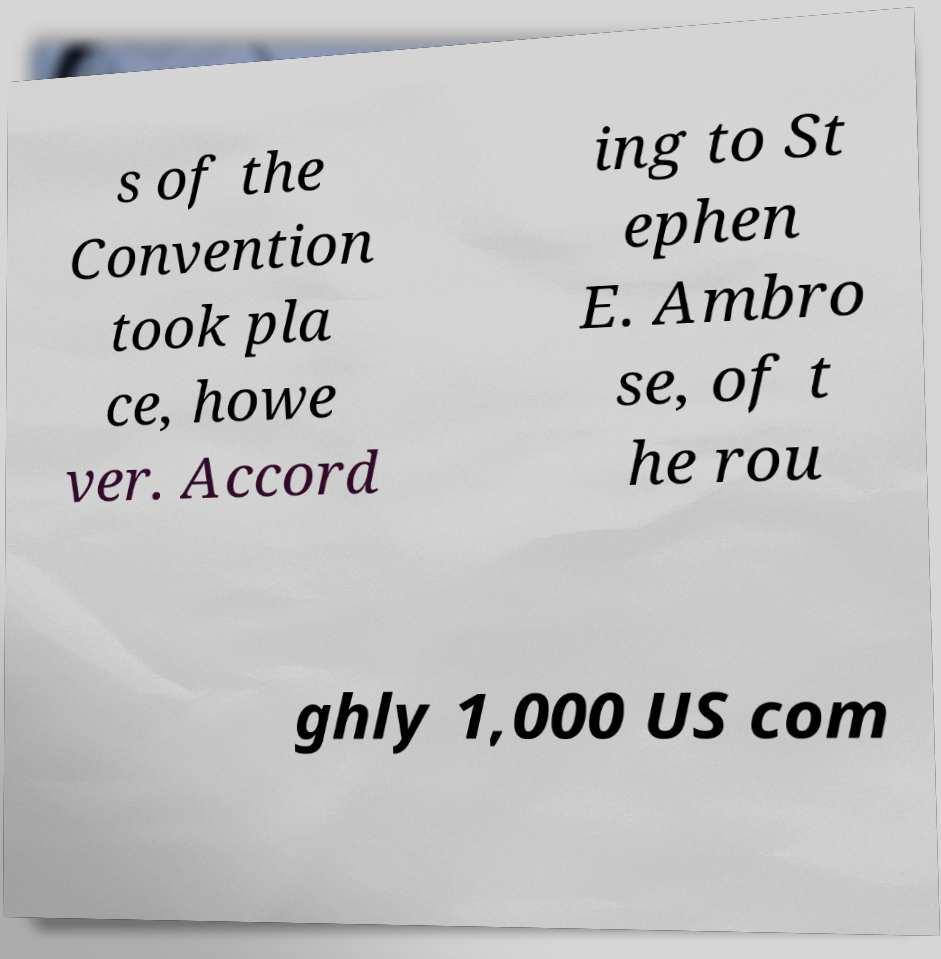Can you accurately transcribe the text from the provided image for me? s of the Convention took pla ce, howe ver. Accord ing to St ephen E. Ambro se, of t he rou ghly 1,000 US com 